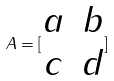<formula> <loc_0><loc_0><loc_500><loc_500>A = [ \begin{matrix} a & b \\ c & d \end{matrix} ]</formula> 